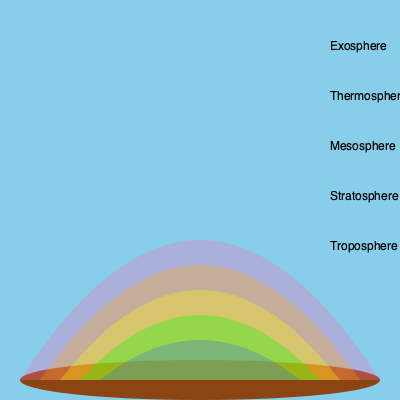In the layered diagram of Earth's atmosphere, which layer is responsible for most of our weather phenomena and contains approximately 75% of the atmosphere's mass? To answer this question, let's examine the layers of the Earth's atmosphere from bottom to top:

1. Troposphere: This is the lowest layer of the atmosphere, extending from the Earth's surface up to about 10-15 km. It contains about 75-80% of the atmosphere's mass and is where most weather phenomena occur.

2. Stratosphere: Located above the troposphere, extending to about 50 km. It contains the ozone layer but has little influence on daily weather.

3. Mesosphere: Extends from the stratosphere to about 85 km. It's where meteors often burn up, but it doesn't significantly affect weather.

4. Thermosphere: This layer can extend from 85 km to 600 km or more. It's where aurora phenomena occur, but it's too high to influence daily weather.

5. Exosphere: The outermost layer, extending from the thermosphere to space. It has very little effect on weather.

Based on this information, the troposphere is the layer responsible for most weather phenomena and contains the majority of the atmosphere's mass.
Answer: Troposphere 